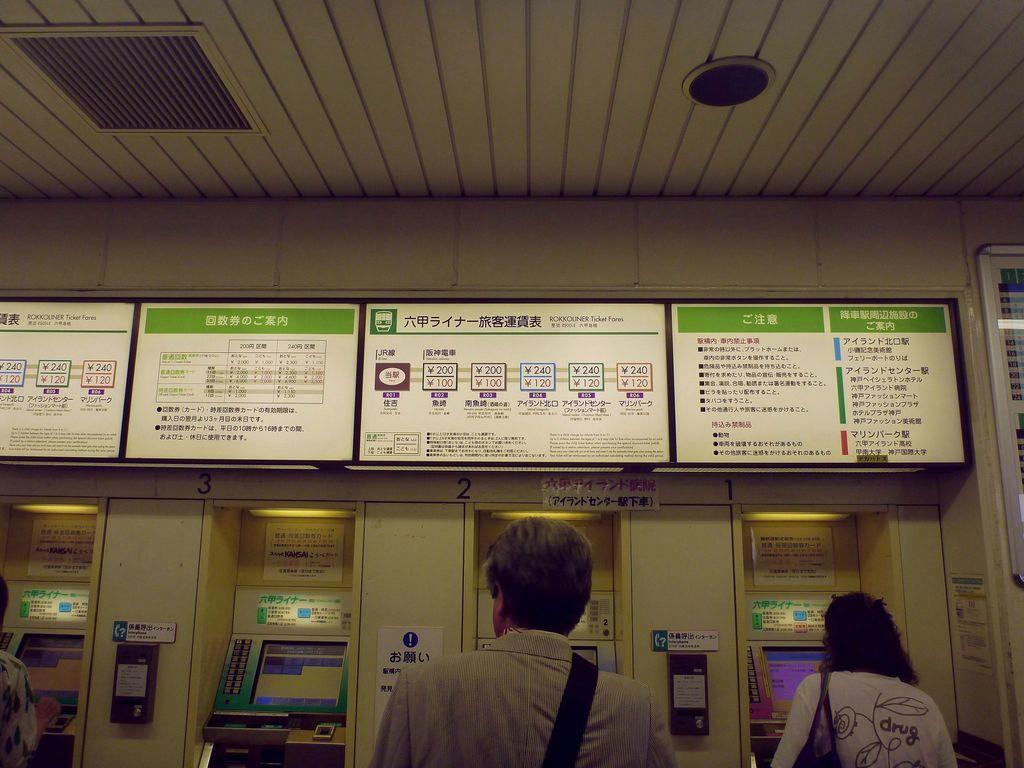What is located in the front of the image? There are persons in the front of the image. What can be seen in the background of the image? There are boards with text and machines in the background of the image. What type of plastic material is being used for the voyage in the image? There is no voyage or plastic material present in the image. 